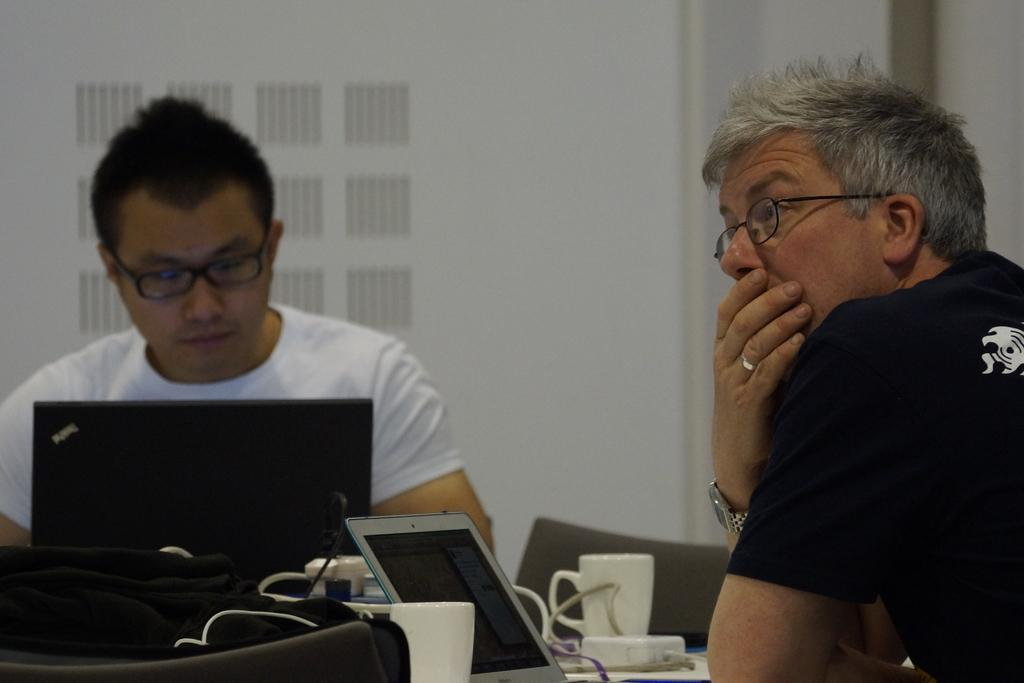How many people are sitting in the image? There are two people sitting in the image. Can you describe the person on the right side of the image? The person on the right side is wearing a watch. What objects can be seen on the table in the image? There are two laptops on the table in the image. How many lizards are crawling on the fifth person in the image? There is no fifth person in the image, and no lizards are present. 